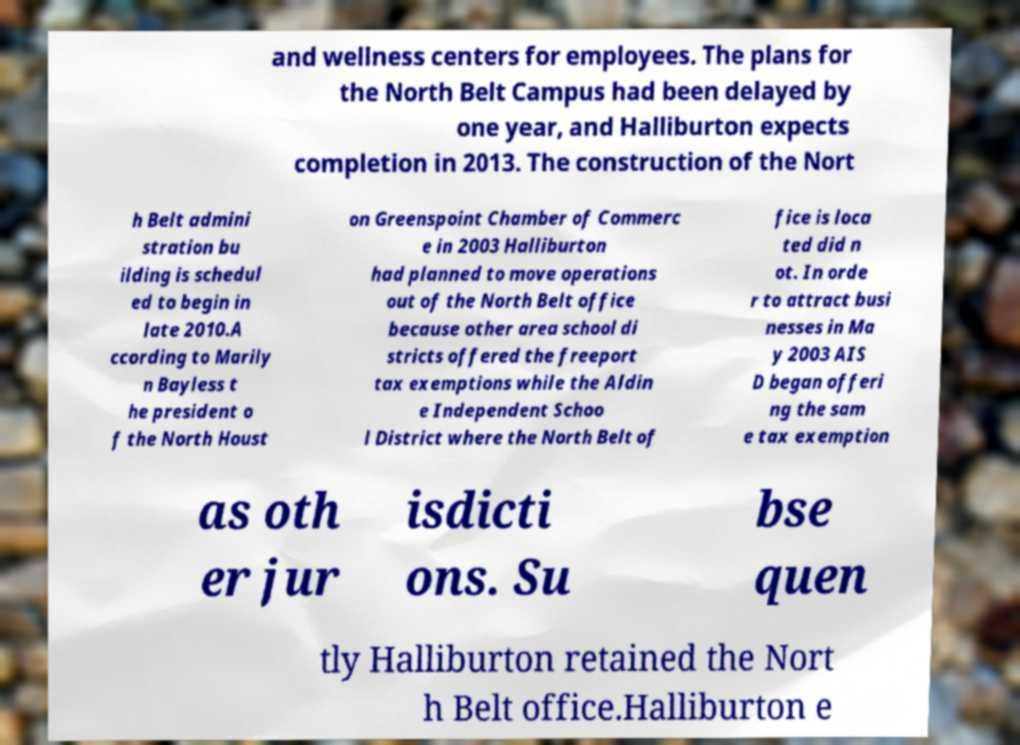There's text embedded in this image that I need extracted. Can you transcribe it verbatim? and wellness centers for employees. The plans for the North Belt Campus had been delayed by one year, and Halliburton expects completion in 2013. The construction of the Nort h Belt admini stration bu ilding is schedul ed to begin in late 2010.A ccording to Marily n Bayless t he president o f the North Houst on Greenspoint Chamber of Commerc e in 2003 Halliburton had planned to move operations out of the North Belt office because other area school di stricts offered the freeport tax exemptions while the Aldin e Independent Schoo l District where the North Belt of fice is loca ted did n ot. In orde r to attract busi nesses in Ma y 2003 AIS D began offeri ng the sam e tax exemption as oth er jur isdicti ons. Su bse quen tly Halliburton retained the Nort h Belt office.Halliburton e 